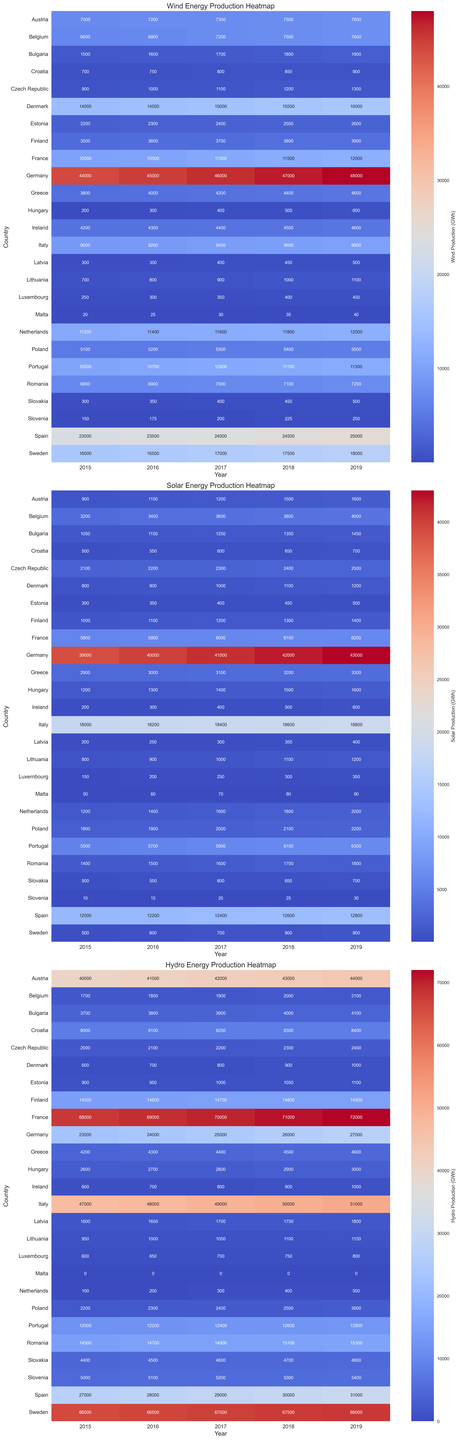Which country has the highest wind energy production in 2019? By examining the heatmap for wind energy and looking at the darkest shaded cell in the 2019 column, we observe that Germany has the highest wind energy production.
Answer: Germany What is the total solar energy production in Belgium across all years? Reviewing the heatmap for solar energy and summing the values for Belgium across the years 2015 to 2019: 3200 + 3400 + 3600 + 3800 + 4000 = 18000.
Answer: 18000 Which country had a higher increase in wind energy production from 2015 to 2019, Spain or Denmark? From the wind energy heatmap, we see that Spain had 23000 in 2015 and 25000 in 2019, an increase of 2000. Denmark had 14000 in 2015 and 16000 in 2019, also an increase of 2000. Both countries had the same increase of 2000.
Answer: Both In which year did France produce the most hydro energy? By inspecting the hydro energy heatmap and checking the values for France, we notice the highest number in the 2019 column, which is 72000. Therefore, 2019 is the year with the highest hydro energy production in France.
Answer: 2019 How does the solar energy production in Sweden in 2015 compare to that of Finland in 2015? Looking at the solar energy heatmap, Sweden produced 500 in 2015, while Finland produced 1000 in the same year. Therefore, Finland produced more solar energy than Sweden in 2015.
Answer: Finland produced more What is the average wind energy production in Denmark over the years 2015 to 2019? From the wind energy heatmap, the values for Denmark from 2015 to 2019 are 14000, 14500, 15000, 15500, 16000. The sum of these values is 75000, and the average is 75000/5 = 15000.
Answer: 15000 Which country had the lowest solar energy production in 2017? By examining the solar energy heatmap for 2017, Malta has the lowest production with a value of 70.
Answer: Malta What is the difference in hydro energy production between Italy and Portugal in 2019? From the hydro energy heatmap, Italy produced 51000 in 2019 and Portugal produced 12800. The difference is 51000 - 12800 = 38200.
Answer: 38200 How did Ireland's wind energy production change from 2015 to 2019? By examining the wind energy heatmap for Ireland, the values from 2015 to 2019 are 4200, 4300, 4400, 4500, 4600. The change is 4600 - 4200 = 400.
Answer: Increased by 400 